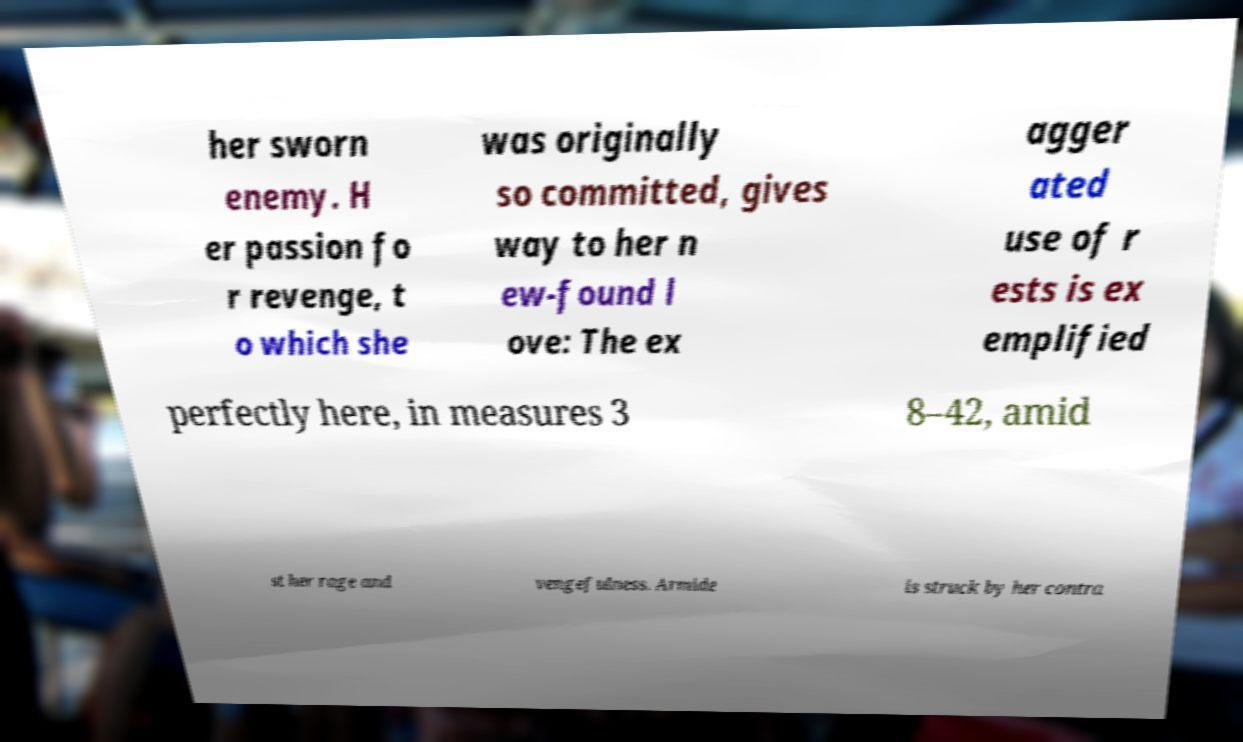Could you assist in decoding the text presented in this image and type it out clearly? her sworn enemy. H er passion fo r revenge, t o which she was originally so committed, gives way to her n ew-found l ove: The ex agger ated use of r ests is ex emplified perfectly here, in measures 3 8–42, amid st her rage and vengefulness. Armide is struck by her contra 